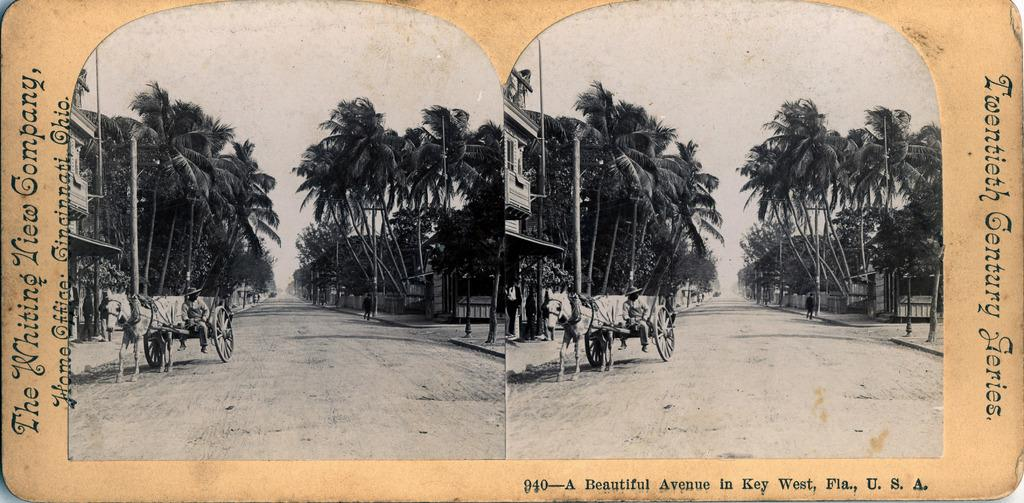How many horse carts are in the image? There are two horse carts in the image. What else can be seen on the road in the image? There are two persons on the road in the image. Can you describe any text visible in the image? Yes, there is text visible in the image. What type of vegetation is present in the image? There are trees in the image. What architectural feature can be seen in the image? There is a fence in the image. What type of structures are visible in the image? There are buildings in the image. What are the two persons on the road doing? Two persons are walking in the image. What is visible in the sky in the image? The sky is visible in the image. How many bottles are visible on the ground in the image? There is no mention of bottles in the image; the provided facts do not mention any bottles. What type of rail is present in the image? There is no rail present in the image; the provided facts do not mention any rails. 